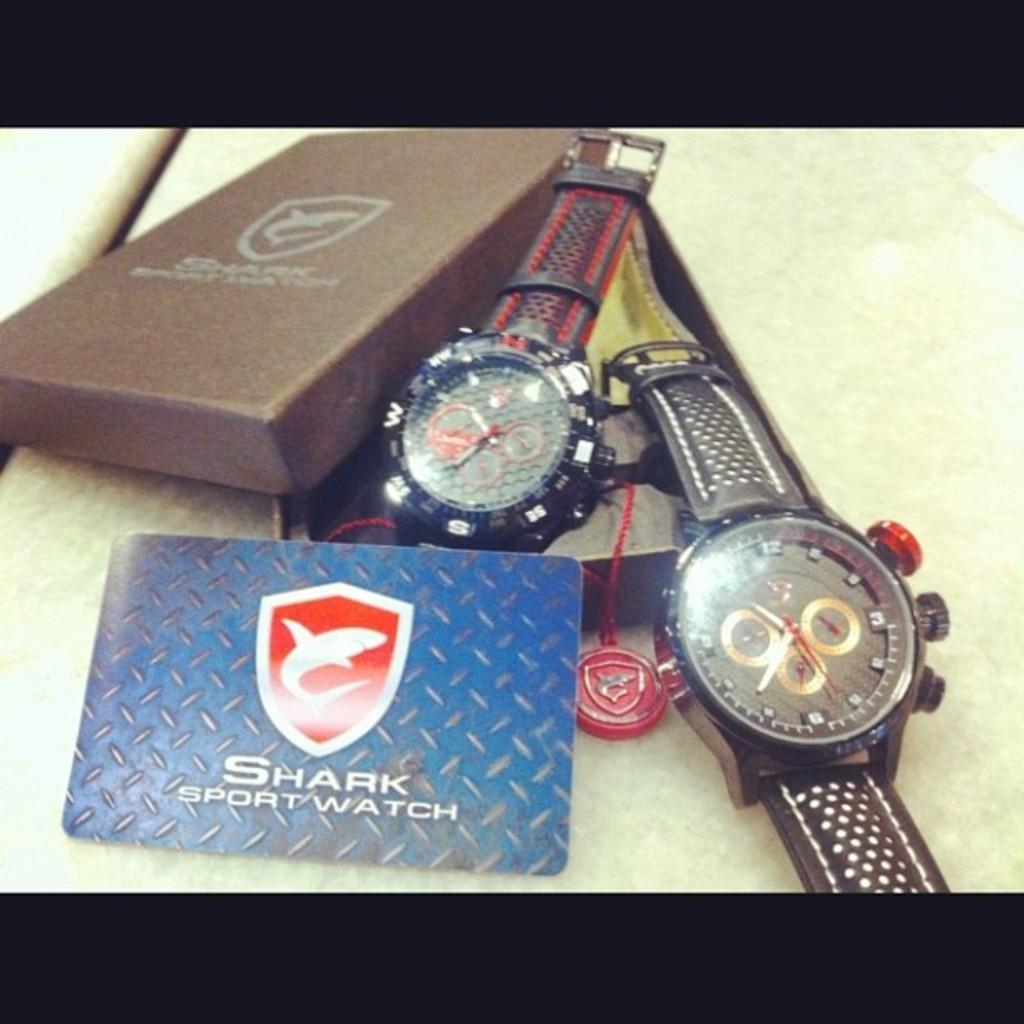Provide a one-sentence caption for the provided image. Two Shark sport watch with the box laying flat. 